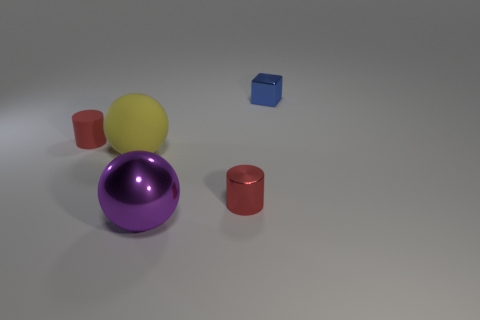Do the matte ball and the shiny ball have the same size?
Offer a terse response. Yes. How big is the purple object?
Provide a succinct answer. Large. What shape is the tiny shiny object that is the same color as the matte cylinder?
Offer a very short reply. Cylinder. Are there more large blue matte blocks than small matte cylinders?
Make the answer very short. No. There is a large ball in front of the large thing on the left side of the sphere that is in front of the red metal cylinder; what is its color?
Your response must be concise. Purple. There is a large object behind the large purple sphere; is its shape the same as the big purple metal thing?
Ensure brevity in your answer.  Yes. There is a shiny thing that is the same size as the blue cube; what is its color?
Make the answer very short. Red. What number of tiny cyan rubber cylinders are there?
Provide a short and direct response. 0. Do the small red thing left of the red metal object and the big yellow thing have the same material?
Make the answer very short. Yes. What material is the small thing that is to the right of the large yellow rubber sphere and in front of the tiny blue metallic block?
Keep it short and to the point. Metal. 